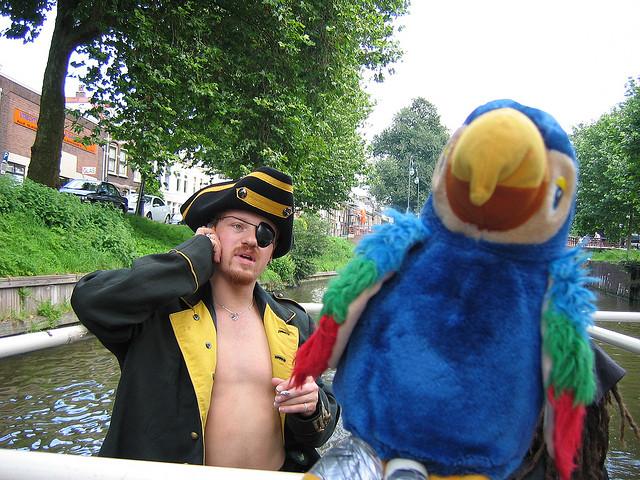What is the man's occupation?
Give a very brief answer. Pirate. Is the man wearing a shirt?
Answer briefly. No. Is the parrot real?
Concise answer only. No. 